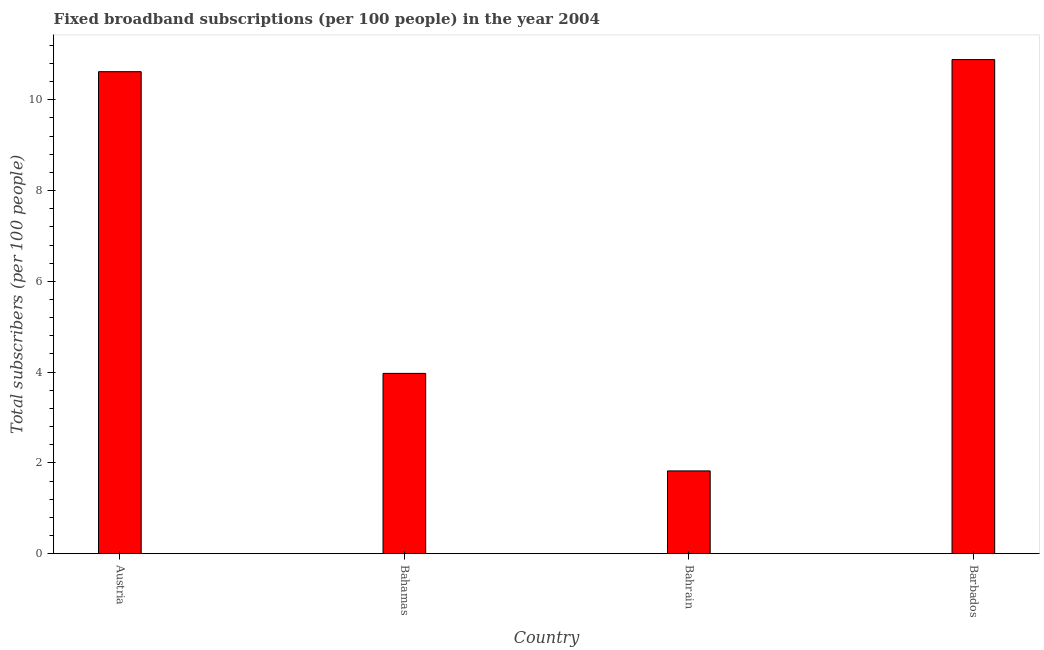Does the graph contain any zero values?
Keep it short and to the point. No. What is the title of the graph?
Provide a short and direct response. Fixed broadband subscriptions (per 100 people) in the year 2004. What is the label or title of the Y-axis?
Provide a succinct answer. Total subscribers (per 100 people). What is the total number of fixed broadband subscriptions in Barbados?
Ensure brevity in your answer.  10.89. Across all countries, what is the maximum total number of fixed broadband subscriptions?
Your answer should be compact. 10.89. Across all countries, what is the minimum total number of fixed broadband subscriptions?
Offer a terse response. 1.82. In which country was the total number of fixed broadband subscriptions maximum?
Keep it short and to the point. Barbados. In which country was the total number of fixed broadband subscriptions minimum?
Make the answer very short. Bahrain. What is the sum of the total number of fixed broadband subscriptions?
Provide a short and direct response. 27.3. What is the difference between the total number of fixed broadband subscriptions in Bahamas and Barbados?
Make the answer very short. -6.91. What is the average total number of fixed broadband subscriptions per country?
Your answer should be compact. 6.82. What is the median total number of fixed broadband subscriptions?
Offer a very short reply. 7.29. In how many countries, is the total number of fixed broadband subscriptions greater than 6 ?
Provide a succinct answer. 2. What is the ratio of the total number of fixed broadband subscriptions in Austria to that in Bahrain?
Keep it short and to the point. 5.83. Is the difference between the total number of fixed broadband subscriptions in Austria and Bahrain greater than the difference between any two countries?
Offer a very short reply. No. What is the difference between the highest and the second highest total number of fixed broadband subscriptions?
Your response must be concise. 0.27. What is the difference between the highest and the lowest total number of fixed broadband subscriptions?
Give a very brief answer. 9.06. How many bars are there?
Make the answer very short. 4. How many countries are there in the graph?
Keep it short and to the point. 4. What is the difference between two consecutive major ticks on the Y-axis?
Offer a very short reply. 2. What is the Total subscribers (per 100 people) of Austria?
Give a very brief answer. 10.62. What is the Total subscribers (per 100 people) of Bahamas?
Give a very brief answer. 3.97. What is the Total subscribers (per 100 people) in Bahrain?
Make the answer very short. 1.82. What is the Total subscribers (per 100 people) of Barbados?
Keep it short and to the point. 10.89. What is the difference between the Total subscribers (per 100 people) in Austria and Bahamas?
Give a very brief answer. 6.65. What is the difference between the Total subscribers (per 100 people) in Austria and Bahrain?
Offer a very short reply. 8.8. What is the difference between the Total subscribers (per 100 people) in Austria and Barbados?
Your answer should be very brief. -0.27. What is the difference between the Total subscribers (per 100 people) in Bahamas and Bahrain?
Your answer should be compact. 2.15. What is the difference between the Total subscribers (per 100 people) in Bahamas and Barbados?
Provide a succinct answer. -6.91. What is the difference between the Total subscribers (per 100 people) in Bahrain and Barbados?
Offer a very short reply. -9.06. What is the ratio of the Total subscribers (per 100 people) in Austria to that in Bahamas?
Offer a terse response. 2.67. What is the ratio of the Total subscribers (per 100 people) in Austria to that in Bahrain?
Your answer should be compact. 5.83. What is the ratio of the Total subscribers (per 100 people) in Bahamas to that in Bahrain?
Your answer should be compact. 2.18. What is the ratio of the Total subscribers (per 100 people) in Bahamas to that in Barbados?
Keep it short and to the point. 0.36. What is the ratio of the Total subscribers (per 100 people) in Bahrain to that in Barbados?
Your answer should be very brief. 0.17. 